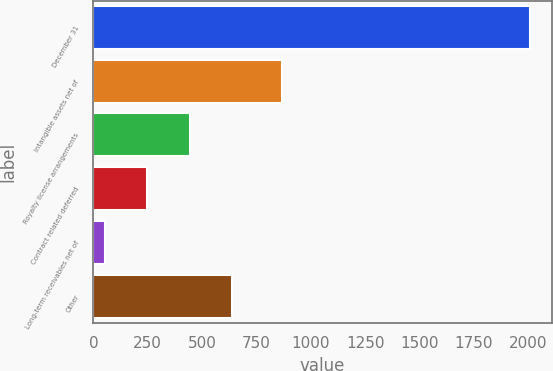Convert chart to OTSL. <chart><loc_0><loc_0><loc_500><loc_500><bar_chart><fcel>December 31<fcel>Intangible assets net of<fcel>Royalty license arrangements<fcel>Contract related deferred<fcel>Long-term receivables net of<fcel>Other<nl><fcel>2008<fcel>869<fcel>443.2<fcel>247.6<fcel>52<fcel>638.8<nl></chart> 